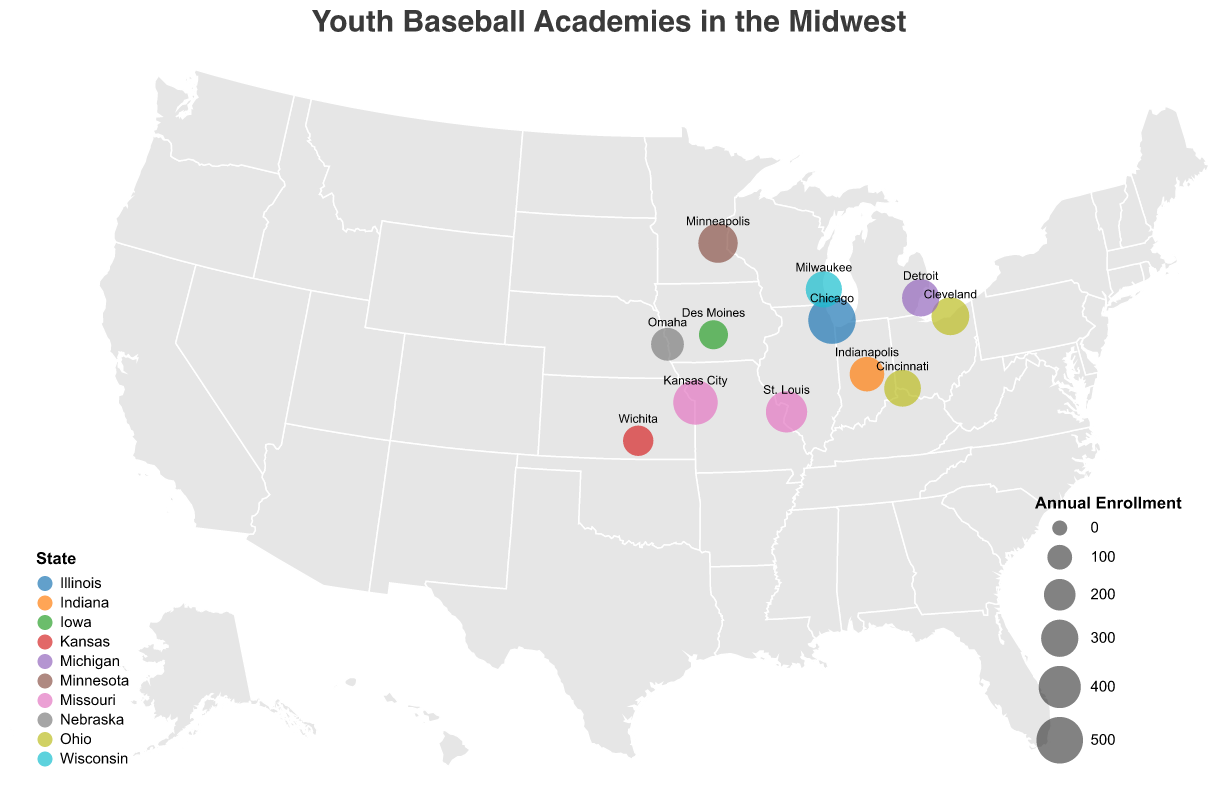Which baseball academy has the highest annual enrollment? From the figure, the size of the circle represents the annual enrollment. The largest circle indicates the Chicago Cubs Baseball Academy has the highest annual enrollment.
Answer: Chicago Cubs Baseball Academy Which states have multiple baseball academies? By examining the color coding on the geographic plot, Missouri and Ohio appear more than once. The data confirms that Missouri has the Kansas City Royals Academy and St. Louis Cardinals Youth Complex; Ohio has Cleveland Guardians Training Center and Cincinnati Reds Baseball Camp.
Answer: Missouri and Ohio What's the total annual enrollment for all facilities in Ohio? Ohio has two facilities: the Cleveland Guardians Training Center and the Cincinnati Reds Baseball Camp. Their enrollments are 310 and 290, respectively. Adding these together yields 310 + 290.
Answer: 600 Which city has the smallest youth baseball academy in terms of annual enrollment? The figure shows that the smallest circle by size is for Des Moines Baseball Factory located in Des Moines, Iowa.
Answer: Des Moines How does the number of baseball academies in Missouri compare to the number in Kansas? Missouri has two academies indicated by two circles, while Kansas has one, indicated by a single circle. So, Missouri has more baseball academies than Kansas.
Answer: Missouri has more What is the average annual enrollment of the baseball academies in Missouri? Missouri has two academies with enrollments of 450 (Kansas City Royals Academy) and 380 (St. Louis Cardinals Youth Complex). The average is calculated by summing the enrollments and dividing by 2 ( (450 + 380) / 2 ).
Answer: 415 How many states have exactly one baseball academy? By examining the color representation of the states and counting the unique appearances, it is observed that Illinois, Minnesota, Wisconsin, Michigan, Kansas, Nebraska, Iowa, and Indiana have one academy each. This sums up to eight states.
Answer: Eight states Is there a visual pattern of enrollment size related to geographic location? The Midwest region shows densest clusters with larger circles (higher enrollments) towards cities like Chicago, Kansas City, and St. Louis, indicating a higher annual enrollment in more populous cities. Smaller cities like Des Moines and Omaha are represented by smaller circles.
Answer: Higher enrollments in populous cities 